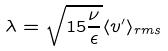Convert formula to latex. <formula><loc_0><loc_0><loc_500><loc_500>\lambda = \sqrt { 1 5 \frac { \nu } { \epsilon } } \langle v ^ { \prime } \rangle _ { r m s }</formula> 